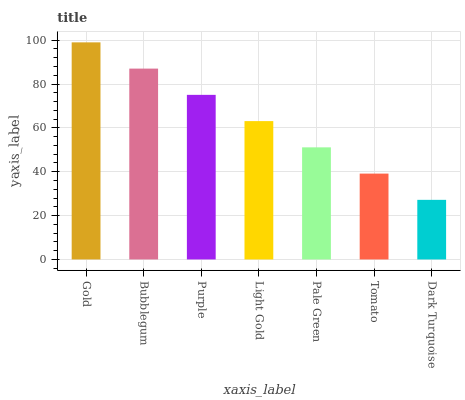Is Dark Turquoise the minimum?
Answer yes or no. Yes. Is Gold the maximum?
Answer yes or no. Yes. Is Bubblegum the minimum?
Answer yes or no. No. Is Bubblegum the maximum?
Answer yes or no. No. Is Gold greater than Bubblegum?
Answer yes or no. Yes. Is Bubblegum less than Gold?
Answer yes or no. Yes. Is Bubblegum greater than Gold?
Answer yes or no. No. Is Gold less than Bubblegum?
Answer yes or no. No. Is Light Gold the high median?
Answer yes or no. Yes. Is Light Gold the low median?
Answer yes or no. Yes. Is Purple the high median?
Answer yes or no. No. Is Purple the low median?
Answer yes or no. No. 